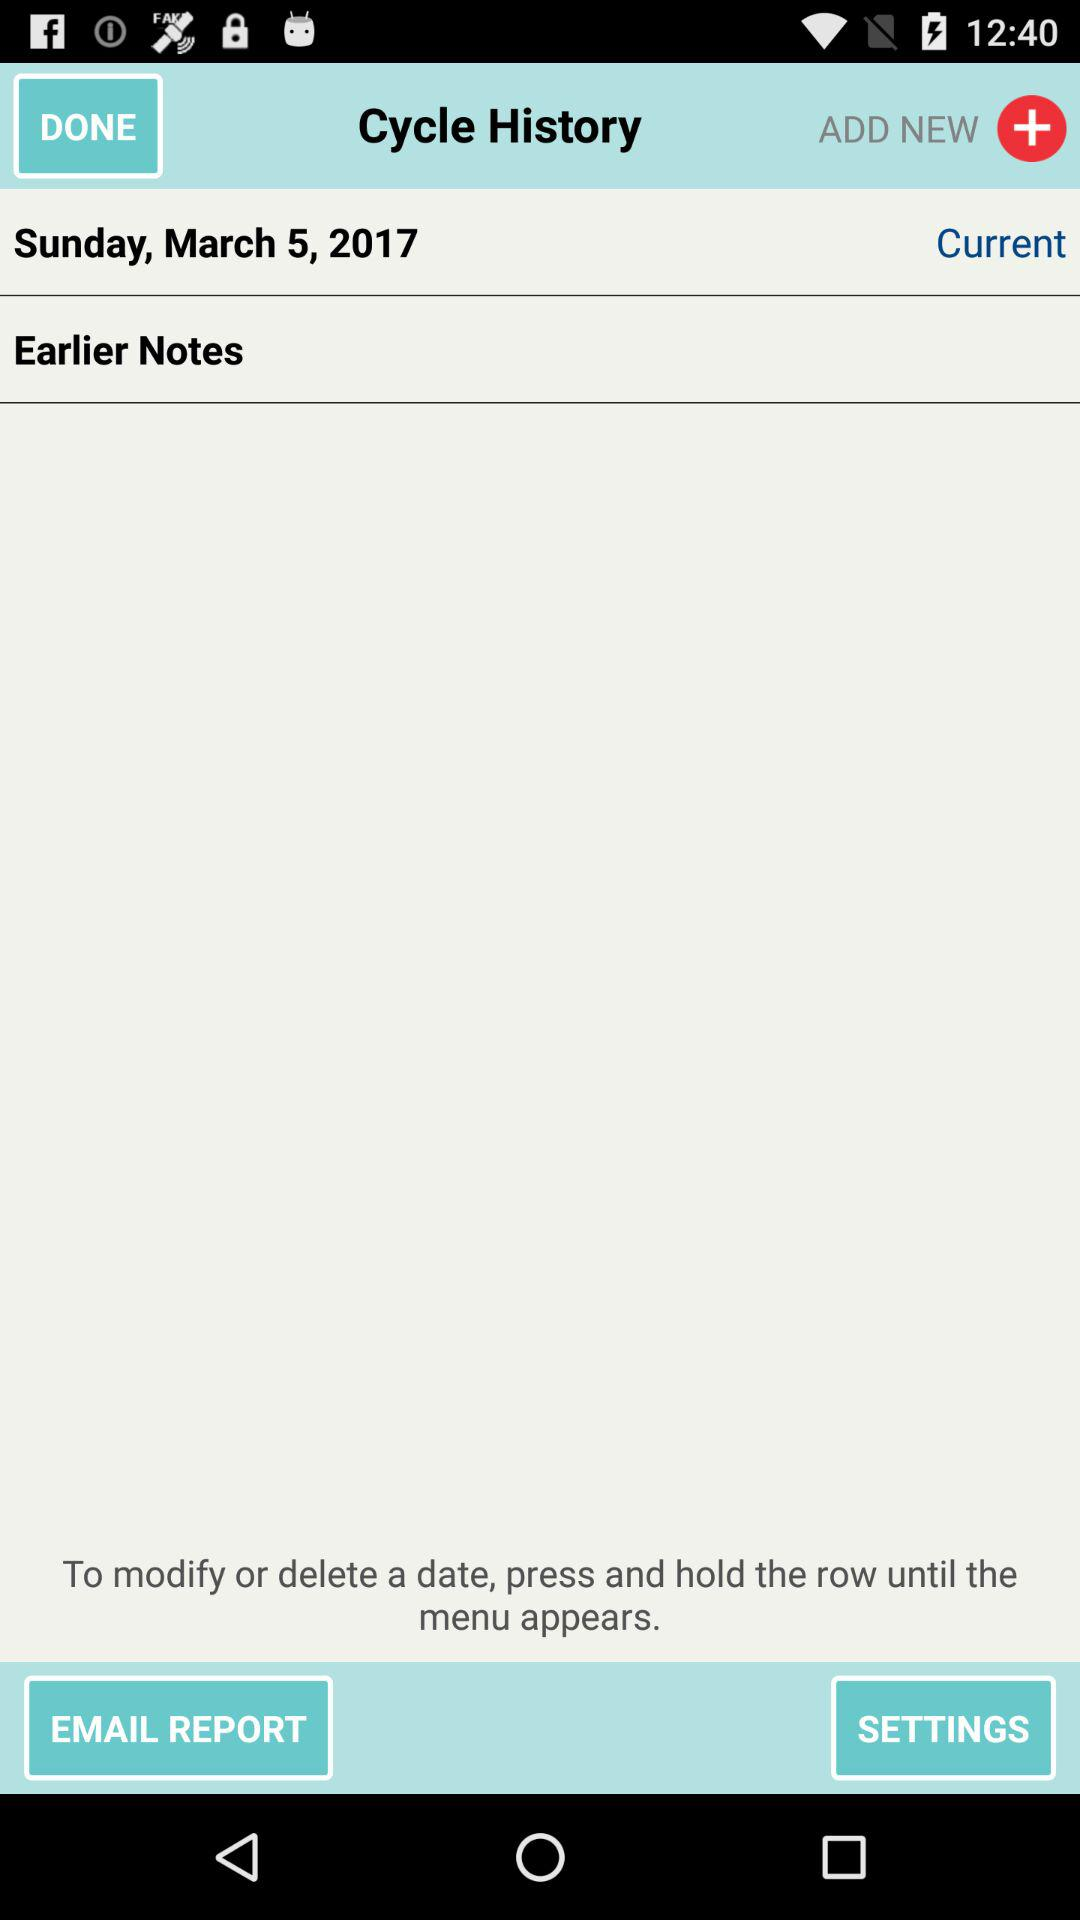What is the current date? The current date is Sunday, March 5, 2017. 